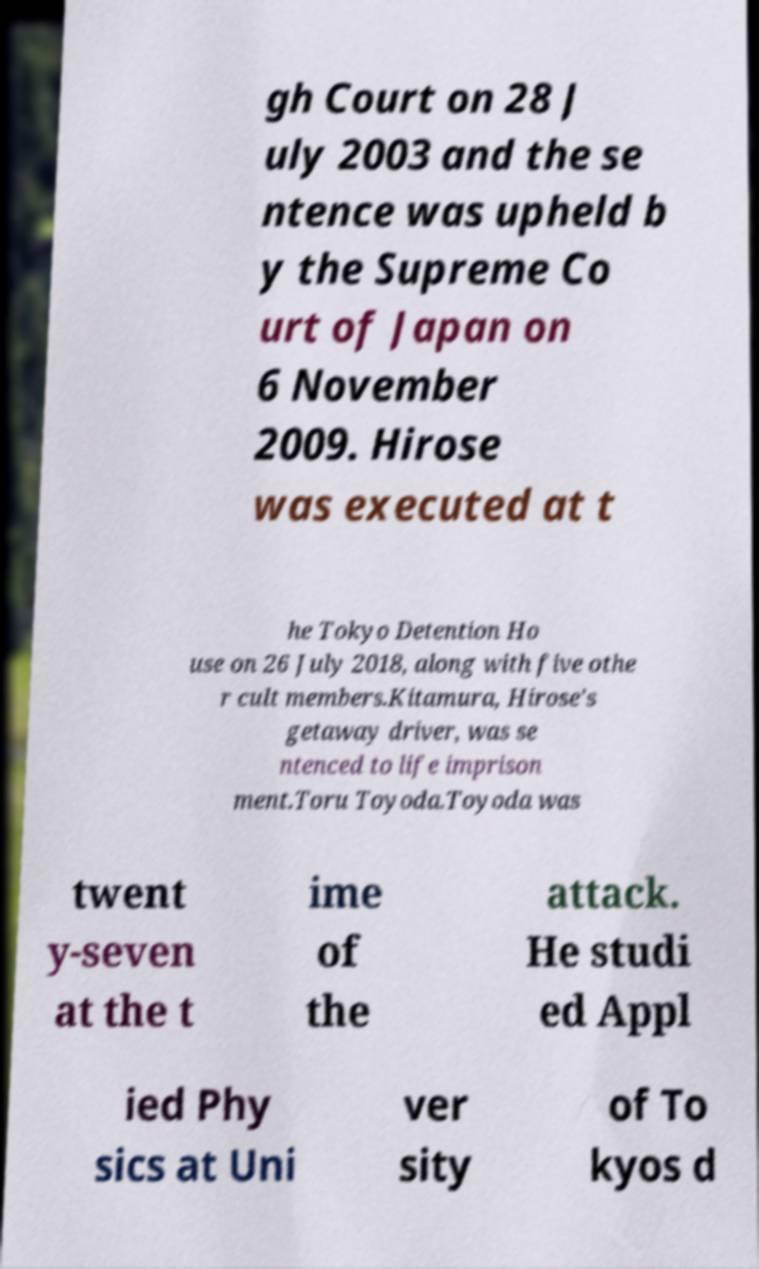I need the written content from this picture converted into text. Can you do that? gh Court on 28 J uly 2003 and the se ntence was upheld b y the Supreme Co urt of Japan on 6 November 2009. Hirose was executed at t he Tokyo Detention Ho use on 26 July 2018, along with five othe r cult members.Kitamura, Hirose's getaway driver, was se ntenced to life imprison ment.Toru Toyoda.Toyoda was twent y-seven at the t ime of the attack. He studi ed Appl ied Phy sics at Uni ver sity of To kyos d 